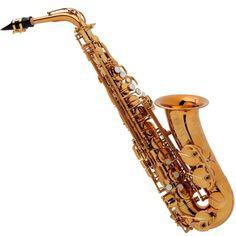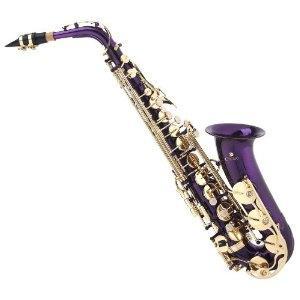The first image is the image on the left, the second image is the image on the right. Evaluate the accuracy of this statement regarding the images: "Both images contain a saxophone that is a blue or purple non-traditional color and all saxophones on the right have the bell facing upwards.". Is it true? Answer yes or no. No. The first image is the image on the left, the second image is the image on the right. Given the left and right images, does the statement "Both of the saxophone bodies share the same rich color, and it is not a traditional metallic (silver or gold) color." hold true? Answer yes or no. No. 